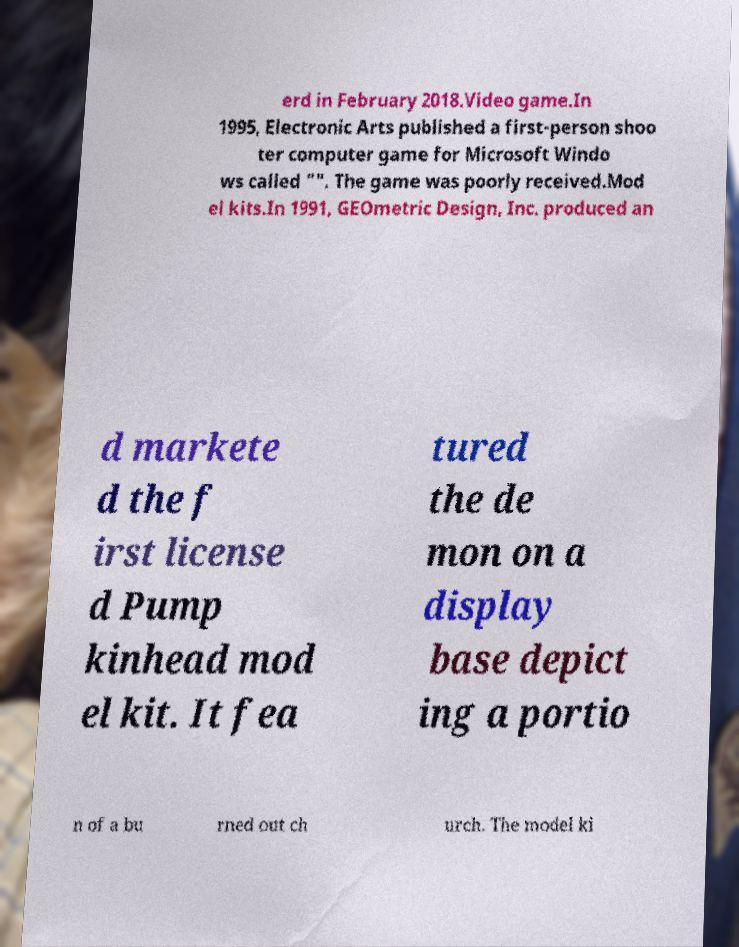What messages or text are displayed in this image? I need them in a readable, typed format. erd in February 2018.Video game.In 1995, Electronic Arts published a first-person shoo ter computer game for Microsoft Windo ws called "". The game was poorly received.Mod el kits.In 1991, GEOmetric Design, Inc. produced an d markete d the f irst license d Pump kinhead mod el kit. It fea tured the de mon on a display base depict ing a portio n of a bu rned out ch urch. The model ki 